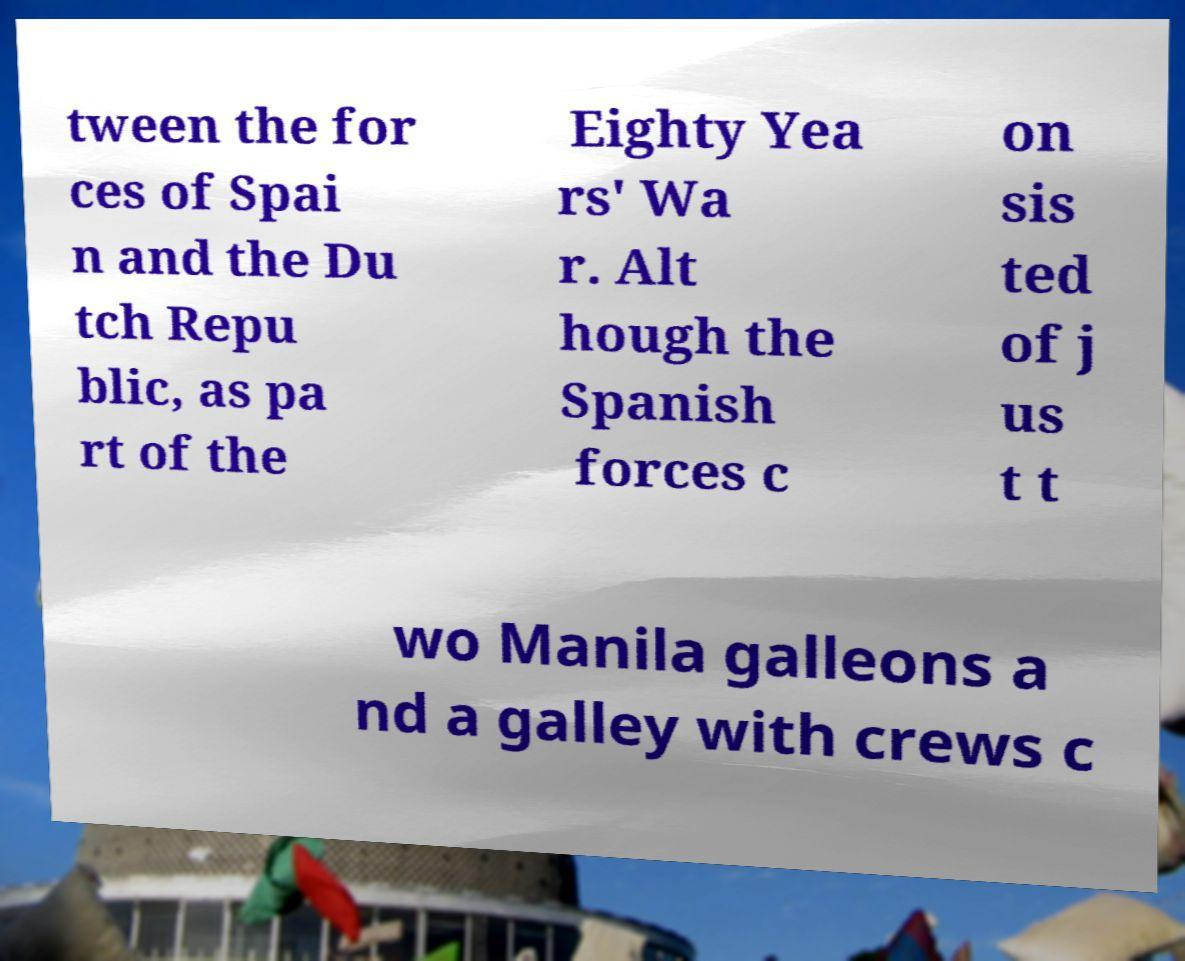Can you read and provide the text displayed in the image?This photo seems to have some interesting text. Can you extract and type it out for me? tween the for ces of Spai n and the Du tch Repu blic, as pa rt of the Eighty Yea rs' Wa r. Alt hough the Spanish forces c on sis ted of j us t t wo Manila galleons a nd a galley with crews c 